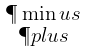Convert formula to latex. <formula><loc_0><loc_0><loc_500><loc_500>\begin{smallmatrix} \P \min u s \\ \P p l u s \end{smallmatrix}</formula> 